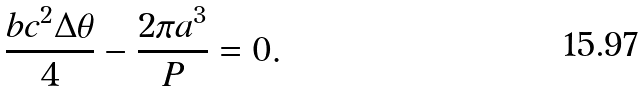<formula> <loc_0><loc_0><loc_500><loc_500>\frac { b c ^ { 2 } \Delta \theta } { 4 } - \frac { 2 \pi a ^ { 3 } } { P } = 0 .</formula> 